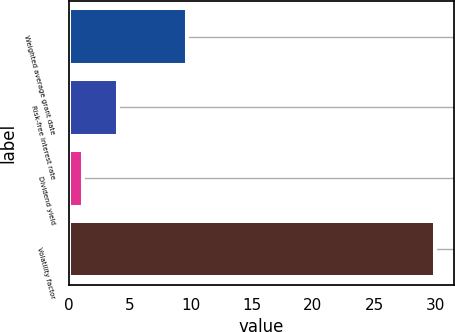Convert chart. <chart><loc_0><loc_0><loc_500><loc_500><bar_chart><fcel>Weighted average grant date<fcel>Risk-free interest rate<fcel>Dividend yield<fcel>Volatility factor<nl><fcel>9.68<fcel>4.07<fcel>1.19<fcel>30<nl></chart> 